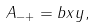Convert formula to latex. <formula><loc_0><loc_0><loc_500><loc_500>A _ { - + } = b x y ,</formula> 